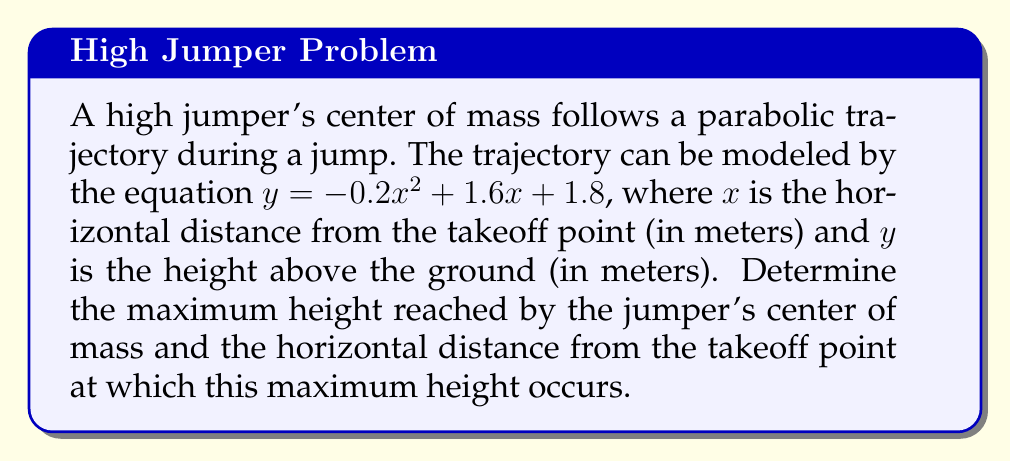Give your solution to this math problem. To solve this problem, we need to follow these steps:

1) The equation of the trajectory is in the form of a quadratic function:
   $y = -0.2x^2 + 1.6x + 1.8$

2) For a quadratic function in the form $y = ax^2 + bx + c$, the x-coordinate of the vertex (which represents the point of maximum height for this parabola) is given by the formula:

   $x = -\frac{b}{2a}$

3) In this case, $a = -0.2$ and $b = 1.6$. Let's substitute these values:

   $x = -\frac{1.6}{2(-0.2)} = -\frac{1.6}{-0.4} = 4$

4) So, the maximum height occurs when $x = 4$ meters from the takeoff point.

5) To find the maximum height, we need to substitute this x-value back into the original equation:

   $y = -0.2(4)^2 + 1.6(4) + 1.8$
   $y = -0.2(16) + 6.4 + 1.8$
   $y = -3.2 + 6.4 + 1.8$
   $y = 5$

Therefore, the maximum height reached by the jumper's center of mass is 5 meters.
Answer: The jumper's center of mass reaches a maximum height of 5 meters at a horizontal distance of 4 meters from the takeoff point. 